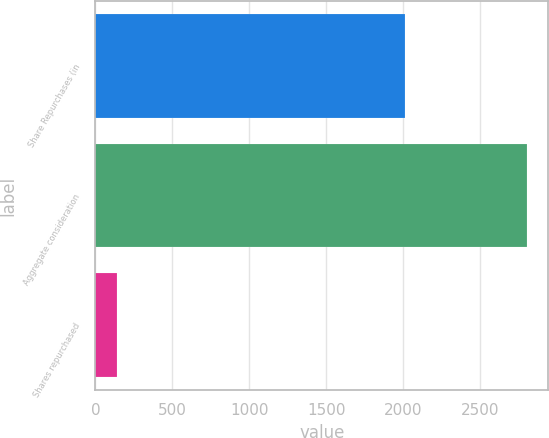Convert chart to OTSL. <chart><loc_0><loc_0><loc_500><loc_500><bar_chart><fcel>Share Repurchases (in<fcel>Aggregate consideration<fcel>Shares repurchased<nl><fcel>2008<fcel>2800<fcel>141<nl></chart> 